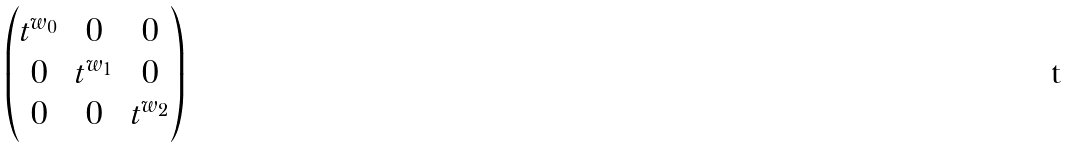Convert formula to latex. <formula><loc_0><loc_0><loc_500><loc_500>\begin{pmatrix} t ^ { w _ { 0 } } & 0 & 0 \\ 0 & t ^ { w _ { 1 } } & 0 \\ 0 & 0 & t ^ { w _ { 2 } } \end{pmatrix}</formula> 